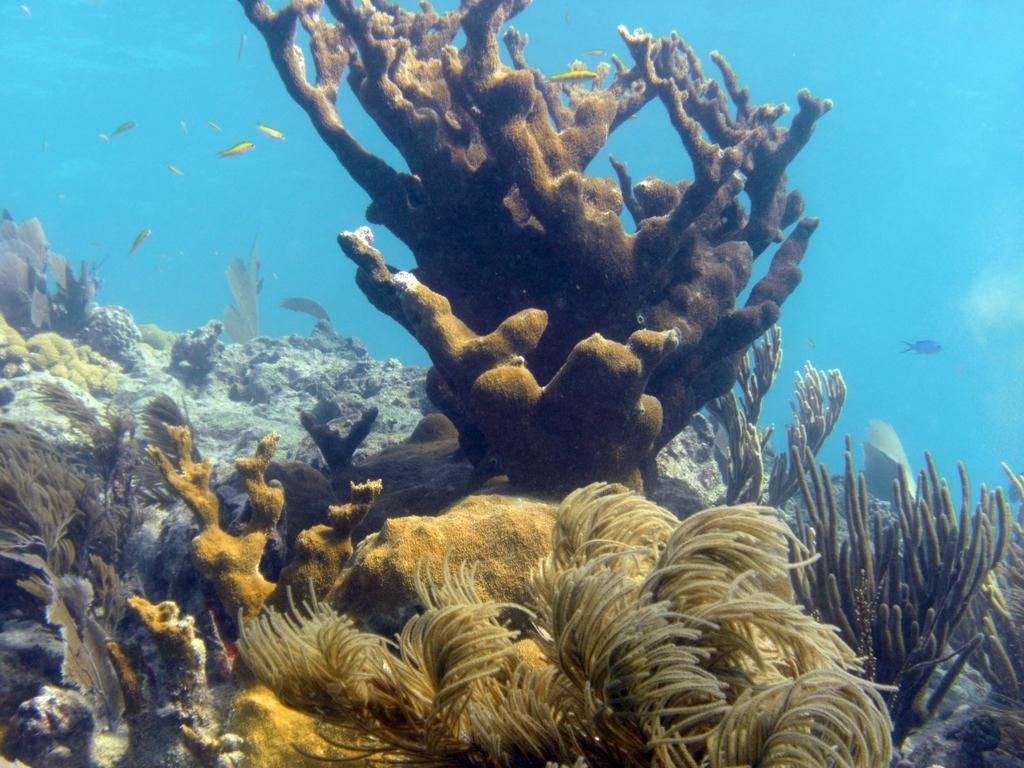What type of animals can be seen in the image? There are fishes in the image. What other elements can be seen in the image besides the fishes? There are water plants in the image. What type of cub can be seen playing with the flame in the image? There is no cub or flame present in the image; it features fishes and water plants. 